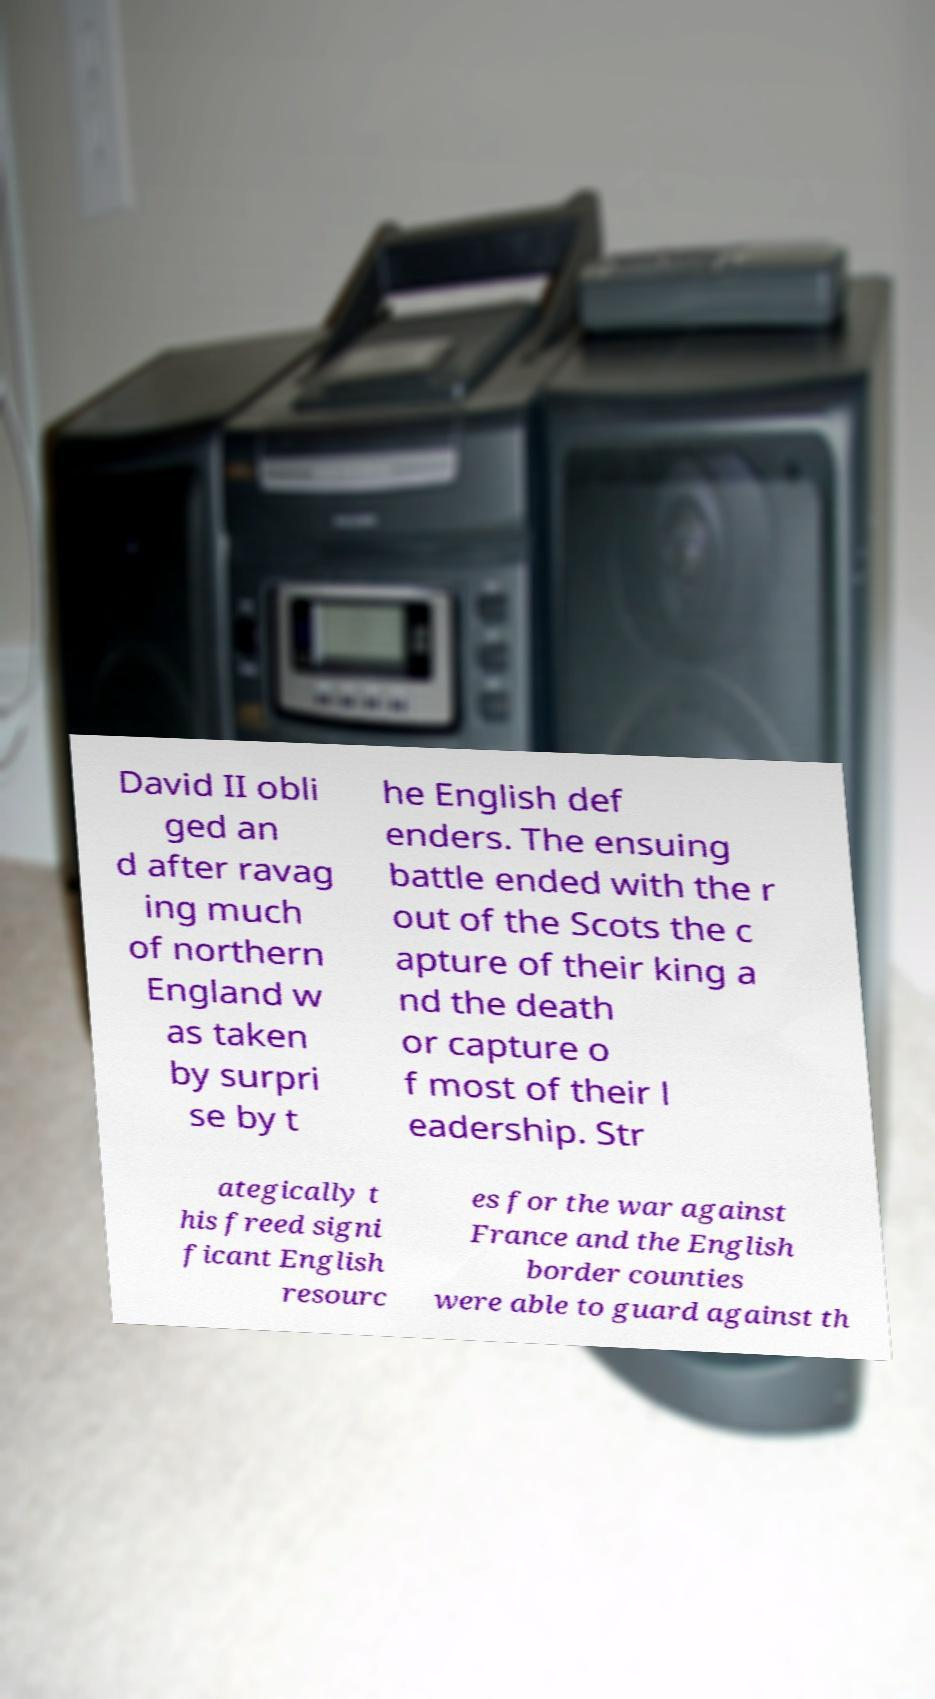There's text embedded in this image that I need extracted. Can you transcribe it verbatim? David II obli ged an d after ravag ing much of northern England w as taken by surpri se by t he English def enders. The ensuing battle ended with the r out of the Scots the c apture of their king a nd the death or capture o f most of their l eadership. Str ategically t his freed signi ficant English resourc es for the war against France and the English border counties were able to guard against th 